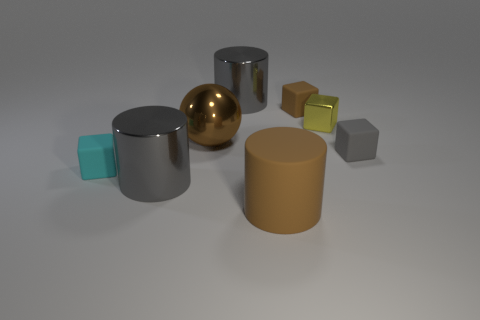Subtract all brown balls. How many gray cylinders are left? 2 Subtract all shiny blocks. How many blocks are left? 3 Subtract 2 blocks. How many blocks are left? 2 Subtract all brown blocks. How many blocks are left? 3 Add 2 cubes. How many objects exist? 10 Subtract all yellow cubes. Subtract all brown cylinders. How many cubes are left? 3 Subtract all metal cylinders. Subtract all brown metal objects. How many objects are left? 5 Add 2 big metal balls. How many big metal balls are left? 3 Add 8 blue matte objects. How many blue matte objects exist? 8 Subtract 0 blue cylinders. How many objects are left? 8 